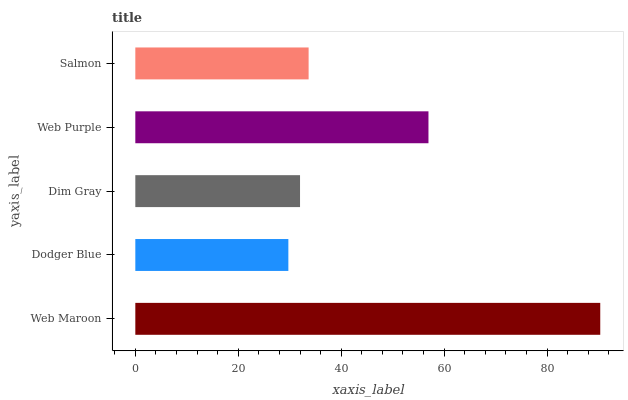Is Dodger Blue the minimum?
Answer yes or no. Yes. Is Web Maroon the maximum?
Answer yes or no. Yes. Is Dim Gray the minimum?
Answer yes or no. No. Is Dim Gray the maximum?
Answer yes or no. No. Is Dim Gray greater than Dodger Blue?
Answer yes or no. Yes. Is Dodger Blue less than Dim Gray?
Answer yes or no. Yes. Is Dodger Blue greater than Dim Gray?
Answer yes or no. No. Is Dim Gray less than Dodger Blue?
Answer yes or no. No. Is Salmon the high median?
Answer yes or no. Yes. Is Salmon the low median?
Answer yes or no. Yes. Is Web Purple the high median?
Answer yes or no. No. Is Web Purple the low median?
Answer yes or no. No. 